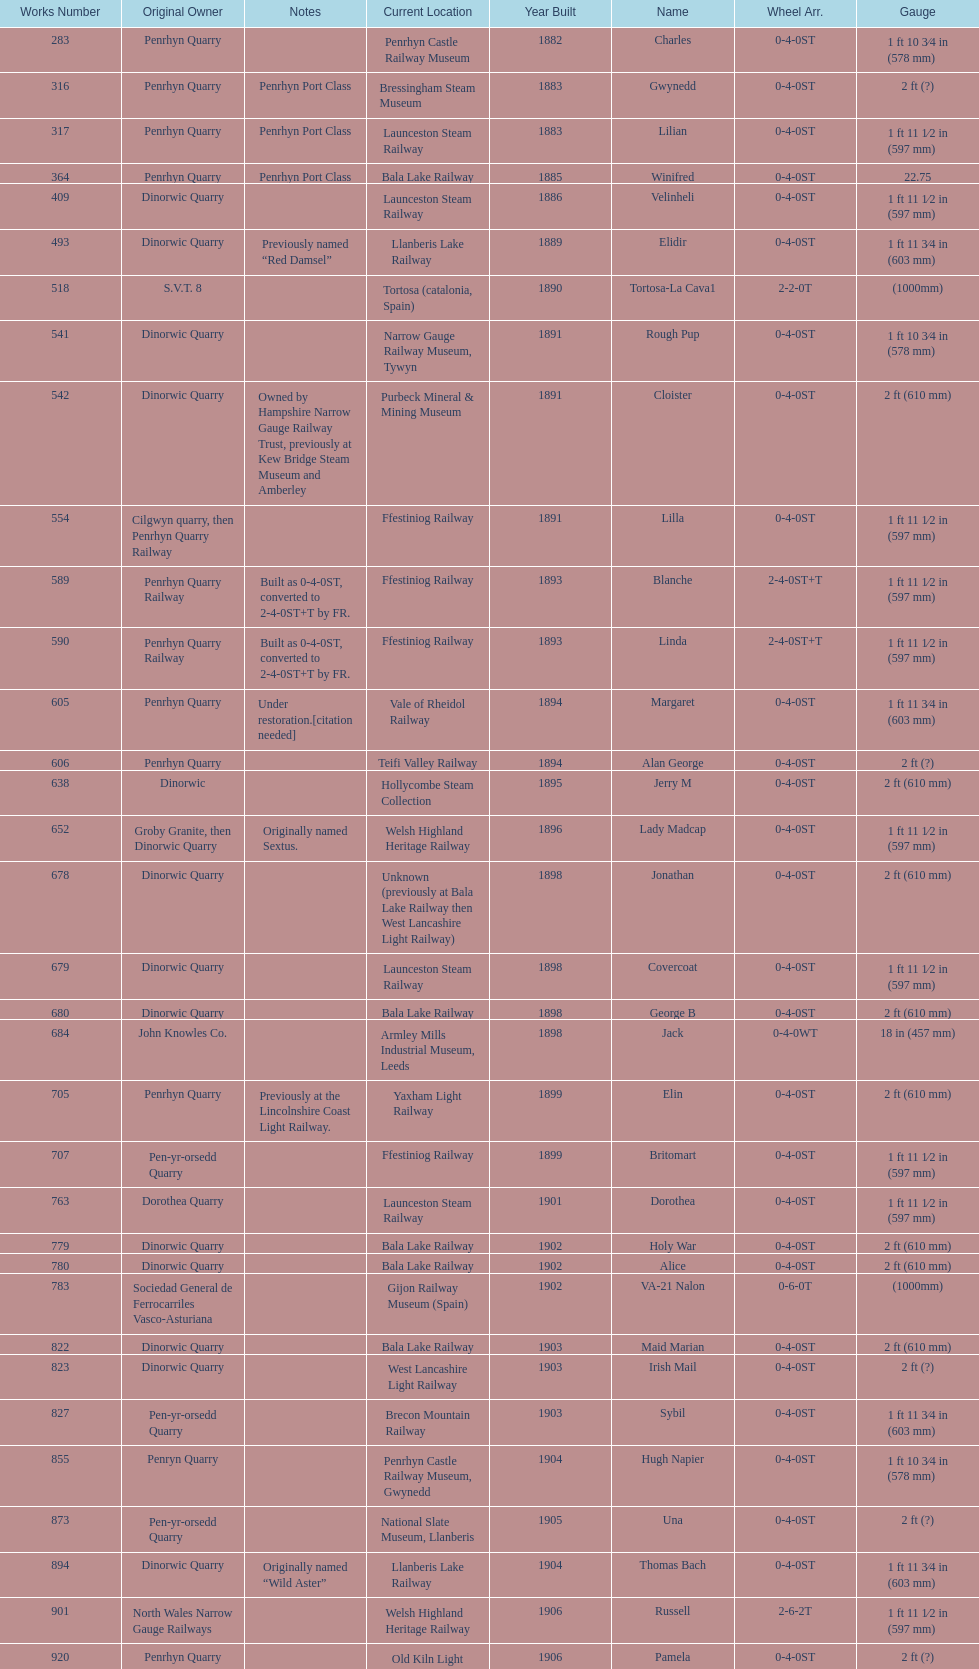Aside from 316, what was the other works number used in 1883? 317. 